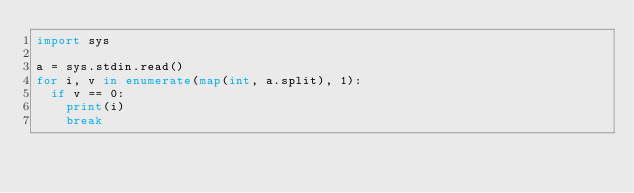Convert code to text. <code><loc_0><loc_0><loc_500><loc_500><_Python_>import sys

a = sys.stdin.read()
for i, v in enumerate(map(int, a.split), 1):
  if v == 0:
    print(i)
    break</code> 